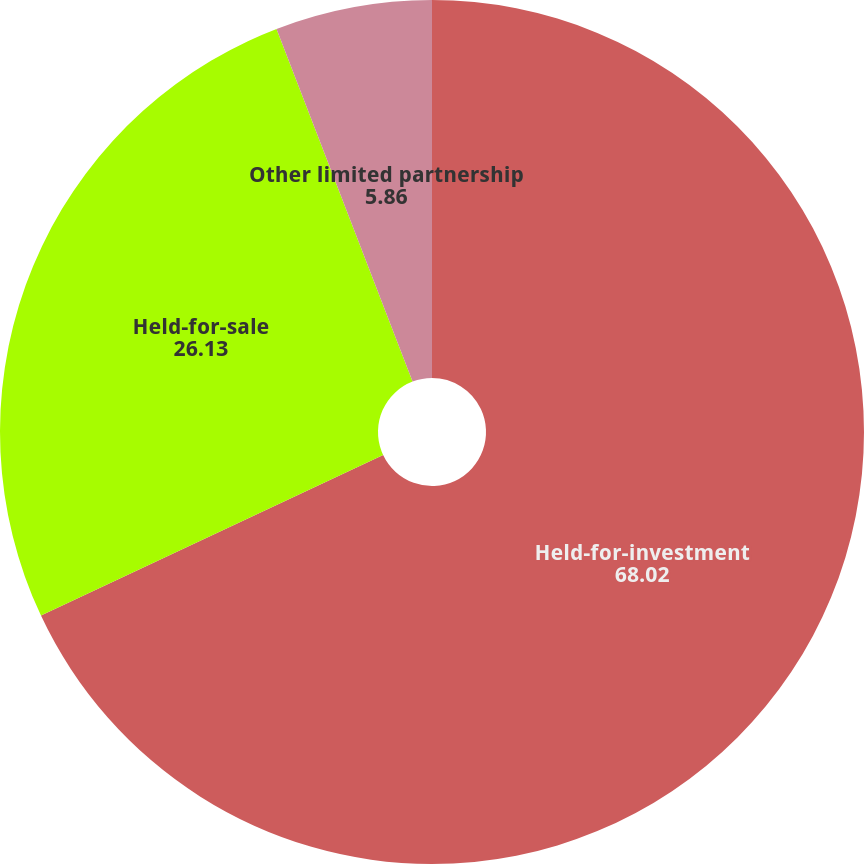Convert chart. <chart><loc_0><loc_0><loc_500><loc_500><pie_chart><fcel>Held-for-investment<fcel>Held-for-sale<fcel>Other limited partnership<nl><fcel>68.02%<fcel>26.13%<fcel>5.86%<nl></chart> 